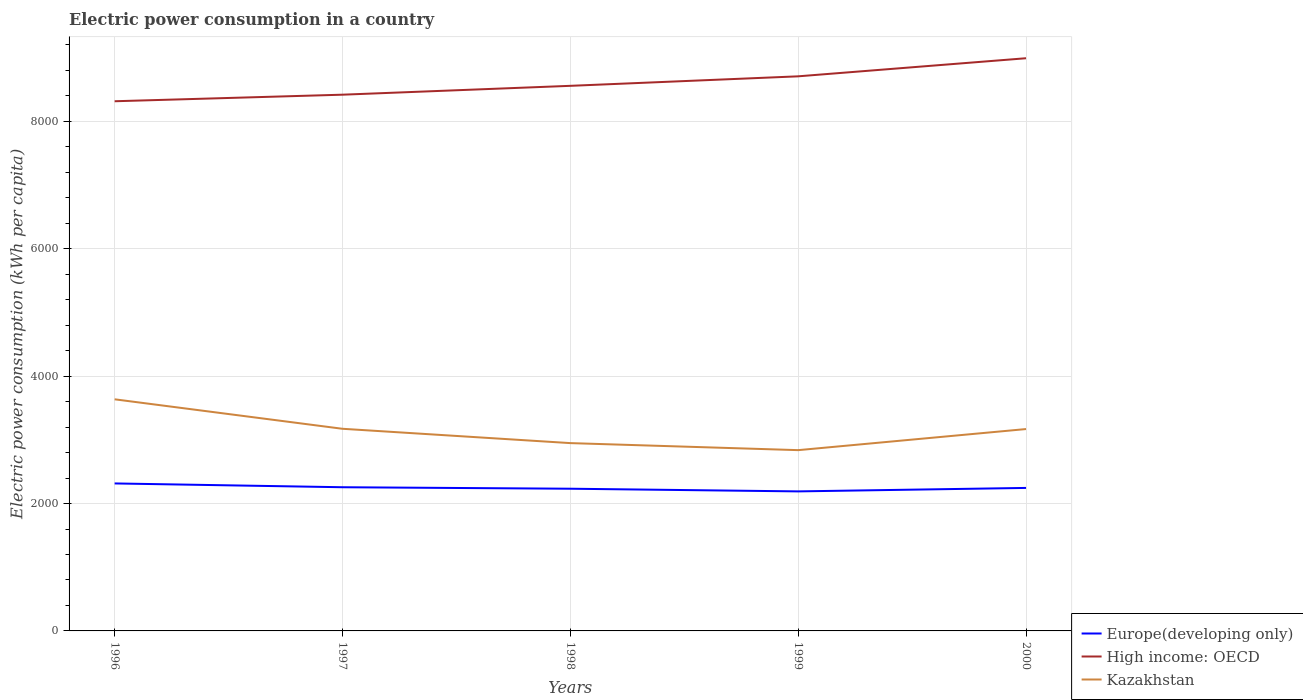Across all years, what is the maximum electric power consumption in in Europe(developing only)?
Provide a short and direct response. 2190.83. What is the total electric power consumption in in Europe(developing only) in the graph?
Offer a terse response. -12.46. What is the difference between the highest and the second highest electric power consumption in in Europe(developing only)?
Give a very brief answer. 124.9. What is the difference between the highest and the lowest electric power consumption in in Kazakhstan?
Make the answer very short. 3. Is the electric power consumption in in Kazakhstan strictly greater than the electric power consumption in in High income: OECD over the years?
Ensure brevity in your answer.  Yes. How many lines are there?
Make the answer very short. 3. How many years are there in the graph?
Your answer should be compact. 5. What is the difference between two consecutive major ticks on the Y-axis?
Offer a terse response. 2000. How many legend labels are there?
Ensure brevity in your answer.  3. How are the legend labels stacked?
Offer a very short reply. Vertical. What is the title of the graph?
Provide a succinct answer. Electric power consumption in a country. Does "El Salvador" appear as one of the legend labels in the graph?
Provide a short and direct response. No. What is the label or title of the X-axis?
Your answer should be very brief. Years. What is the label or title of the Y-axis?
Give a very brief answer. Electric power consumption (kWh per capita). What is the Electric power consumption (kWh per capita) of Europe(developing only) in 1996?
Your answer should be very brief. 2315.73. What is the Electric power consumption (kWh per capita) of High income: OECD in 1996?
Offer a very short reply. 8316.45. What is the Electric power consumption (kWh per capita) in Kazakhstan in 1996?
Your answer should be compact. 3636.63. What is the Electric power consumption (kWh per capita) of Europe(developing only) in 1997?
Offer a very short reply. 2256.15. What is the Electric power consumption (kWh per capita) of High income: OECD in 1997?
Give a very brief answer. 8419.43. What is the Electric power consumption (kWh per capita) of Kazakhstan in 1997?
Provide a succinct answer. 3173.79. What is the Electric power consumption (kWh per capita) of Europe(developing only) in 1998?
Make the answer very short. 2232.69. What is the Electric power consumption (kWh per capita) of High income: OECD in 1998?
Give a very brief answer. 8558.64. What is the Electric power consumption (kWh per capita) in Kazakhstan in 1998?
Make the answer very short. 2948.78. What is the Electric power consumption (kWh per capita) in Europe(developing only) in 1999?
Your response must be concise. 2190.83. What is the Electric power consumption (kWh per capita) of High income: OECD in 1999?
Your response must be concise. 8707.81. What is the Electric power consumption (kWh per capita) in Kazakhstan in 1999?
Your answer should be very brief. 2838.34. What is the Electric power consumption (kWh per capita) in Europe(developing only) in 2000?
Your response must be concise. 2245.15. What is the Electric power consumption (kWh per capita) of High income: OECD in 2000?
Provide a succinct answer. 8991.83. What is the Electric power consumption (kWh per capita) in Kazakhstan in 2000?
Provide a succinct answer. 3169.52. Across all years, what is the maximum Electric power consumption (kWh per capita) in Europe(developing only)?
Your response must be concise. 2315.73. Across all years, what is the maximum Electric power consumption (kWh per capita) in High income: OECD?
Your response must be concise. 8991.83. Across all years, what is the maximum Electric power consumption (kWh per capita) of Kazakhstan?
Give a very brief answer. 3636.63. Across all years, what is the minimum Electric power consumption (kWh per capita) in Europe(developing only)?
Ensure brevity in your answer.  2190.83. Across all years, what is the minimum Electric power consumption (kWh per capita) of High income: OECD?
Provide a succinct answer. 8316.45. Across all years, what is the minimum Electric power consumption (kWh per capita) of Kazakhstan?
Provide a short and direct response. 2838.34. What is the total Electric power consumption (kWh per capita) in Europe(developing only) in the graph?
Your answer should be compact. 1.12e+04. What is the total Electric power consumption (kWh per capita) in High income: OECD in the graph?
Make the answer very short. 4.30e+04. What is the total Electric power consumption (kWh per capita) in Kazakhstan in the graph?
Provide a succinct answer. 1.58e+04. What is the difference between the Electric power consumption (kWh per capita) of Europe(developing only) in 1996 and that in 1997?
Provide a short and direct response. 59.58. What is the difference between the Electric power consumption (kWh per capita) in High income: OECD in 1996 and that in 1997?
Offer a very short reply. -102.97. What is the difference between the Electric power consumption (kWh per capita) in Kazakhstan in 1996 and that in 1997?
Make the answer very short. 462.83. What is the difference between the Electric power consumption (kWh per capita) in Europe(developing only) in 1996 and that in 1998?
Offer a terse response. 83.04. What is the difference between the Electric power consumption (kWh per capita) of High income: OECD in 1996 and that in 1998?
Your answer should be compact. -242.18. What is the difference between the Electric power consumption (kWh per capita) of Kazakhstan in 1996 and that in 1998?
Your answer should be very brief. 687.84. What is the difference between the Electric power consumption (kWh per capita) in Europe(developing only) in 1996 and that in 1999?
Offer a very short reply. 124.9. What is the difference between the Electric power consumption (kWh per capita) in High income: OECD in 1996 and that in 1999?
Provide a succinct answer. -391.35. What is the difference between the Electric power consumption (kWh per capita) of Kazakhstan in 1996 and that in 1999?
Ensure brevity in your answer.  798.28. What is the difference between the Electric power consumption (kWh per capita) of Europe(developing only) in 1996 and that in 2000?
Provide a succinct answer. 70.58. What is the difference between the Electric power consumption (kWh per capita) of High income: OECD in 1996 and that in 2000?
Give a very brief answer. -675.37. What is the difference between the Electric power consumption (kWh per capita) in Kazakhstan in 1996 and that in 2000?
Provide a short and direct response. 467.1. What is the difference between the Electric power consumption (kWh per capita) of Europe(developing only) in 1997 and that in 1998?
Your response must be concise. 23.46. What is the difference between the Electric power consumption (kWh per capita) of High income: OECD in 1997 and that in 1998?
Offer a terse response. -139.21. What is the difference between the Electric power consumption (kWh per capita) in Kazakhstan in 1997 and that in 1998?
Your response must be concise. 225.01. What is the difference between the Electric power consumption (kWh per capita) of Europe(developing only) in 1997 and that in 1999?
Keep it short and to the point. 65.32. What is the difference between the Electric power consumption (kWh per capita) of High income: OECD in 1997 and that in 1999?
Offer a terse response. -288.38. What is the difference between the Electric power consumption (kWh per capita) in Kazakhstan in 1997 and that in 1999?
Make the answer very short. 335.45. What is the difference between the Electric power consumption (kWh per capita) of Europe(developing only) in 1997 and that in 2000?
Provide a short and direct response. 11. What is the difference between the Electric power consumption (kWh per capita) of High income: OECD in 1997 and that in 2000?
Your answer should be compact. -572.4. What is the difference between the Electric power consumption (kWh per capita) in Kazakhstan in 1997 and that in 2000?
Offer a very short reply. 4.27. What is the difference between the Electric power consumption (kWh per capita) of Europe(developing only) in 1998 and that in 1999?
Your answer should be very brief. 41.86. What is the difference between the Electric power consumption (kWh per capita) in High income: OECD in 1998 and that in 1999?
Offer a very short reply. -149.17. What is the difference between the Electric power consumption (kWh per capita) in Kazakhstan in 1998 and that in 1999?
Provide a short and direct response. 110.44. What is the difference between the Electric power consumption (kWh per capita) in Europe(developing only) in 1998 and that in 2000?
Provide a succinct answer. -12.46. What is the difference between the Electric power consumption (kWh per capita) of High income: OECD in 1998 and that in 2000?
Ensure brevity in your answer.  -433.19. What is the difference between the Electric power consumption (kWh per capita) in Kazakhstan in 1998 and that in 2000?
Offer a terse response. -220.74. What is the difference between the Electric power consumption (kWh per capita) in Europe(developing only) in 1999 and that in 2000?
Keep it short and to the point. -54.33. What is the difference between the Electric power consumption (kWh per capita) of High income: OECD in 1999 and that in 2000?
Your response must be concise. -284.02. What is the difference between the Electric power consumption (kWh per capita) in Kazakhstan in 1999 and that in 2000?
Keep it short and to the point. -331.18. What is the difference between the Electric power consumption (kWh per capita) in Europe(developing only) in 1996 and the Electric power consumption (kWh per capita) in High income: OECD in 1997?
Offer a terse response. -6103.7. What is the difference between the Electric power consumption (kWh per capita) of Europe(developing only) in 1996 and the Electric power consumption (kWh per capita) of Kazakhstan in 1997?
Your response must be concise. -858.06. What is the difference between the Electric power consumption (kWh per capita) of High income: OECD in 1996 and the Electric power consumption (kWh per capita) of Kazakhstan in 1997?
Provide a short and direct response. 5142.66. What is the difference between the Electric power consumption (kWh per capita) of Europe(developing only) in 1996 and the Electric power consumption (kWh per capita) of High income: OECD in 1998?
Give a very brief answer. -6242.91. What is the difference between the Electric power consumption (kWh per capita) in Europe(developing only) in 1996 and the Electric power consumption (kWh per capita) in Kazakhstan in 1998?
Provide a succinct answer. -633.05. What is the difference between the Electric power consumption (kWh per capita) of High income: OECD in 1996 and the Electric power consumption (kWh per capita) of Kazakhstan in 1998?
Provide a short and direct response. 5367.67. What is the difference between the Electric power consumption (kWh per capita) of Europe(developing only) in 1996 and the Electric power consumption (kWh per capita) of High income: OECD in 1999?
Offer a terse response. -6392.08. What is the difference between the Electric power consumption (kWh per capita) of Europe(developing only) in 1996 and the Electric power consumption (kWh per capita) of Kazakhstan in 1999?
Ensure brevity in your answer.  -522.61. What is the difference between the Electric power consumption (kWh per capita) in High income: OECD in 1996 and the Electric power consumption (kWh per capita) in Kazakhstan in 1999?
Your answer should be very brief. 5478.11. What is the difference between the Electric power consumption (kWh per capita) in Europe(developing only) in 1996 and the Electric power consumption (kWh per capita) in High income: OECD in 2000?
Offer a very short reply. -6676.1. What is the difference between the Electric power consumption (kWh per capita) in Europe(developing only) in 1996 and the Electric power consumption (kWh per capita) in Kazakhstan in 2000?
Make the answer very short. -853.79. What is the difference between the Electric power consumption (kWh per capita) of High income: OECD in 1996 and the Electric power consumption (kWh per capita) of Kazakhstan in 2000?
Ensure brevity in your answer.  5146.93. What is the difference between the Electric power consumption (kWh per capita) in Europe(developing only) in 1997 and the Electric power consumption (kWh per capita) in High income: OECD in 1998?
Provide a short and direct response. -6302.49. What is the difference between the Electric power consumption (kWh per capita) in Europe(developing only) in 1997 and the Electric power consumption (kWh per capita) in Kazakhstan in 1998?
Offer a terse response. -692.64. What is the difference between the Electric power consumption (kWh per capita) in High income: OECD in 1997 and the Electric power consumption (kWh per capita) in Kazakhstan in 1998?
Make the answer very short. 5470.64. What is the difference between the Electric power consumption (kWh per capita) of Europe(developing only) in 1997 and the Electric power consumption (kWh per capita) of High income: OECD in 1999?
Ensure brevity in your answer.  -6451.66. What is the difference between the Electric power consumption (kWh per capita) in Europe(developing only) in 1997 and the Electric power consumption (kWh per capita) in Kazakhstan in 1999?
Provide a succinct answer. -582.2. What is the difference between the Electric power consumption (kWh per capita) in High income: OECD in 1997 and the Electric power consumption (kWh per capita) in Kazakhstan in 1999?
Offer a very short reply. 5581.08. What is the difference between the Electric power consumption (kWh per capita) in Europe(developing only) in 1997 and the Electric power consumption (kWh per capita) in High income: OECD in 2000?
Your answer should be compact. -6735.68. What is the difference between the Electric power consumption (kWh per capita) in Europe(developing only) in 1997 and the Electric power consumption (kWh per capita) in Kazakhstan in 2000?
Provide a short and direct response. -913.38. What is the difference between the Electric power consumption (kWh per capita) in High income: OECD in 1997 and the Electric power consumption (kWh per capita) in Kazakhstan in 2000?
Your response must be concise. 5249.9. What is the difference between the Electric power consumption (kWh per capita) in Europe(developing only) in 1998 and the Electric power consumption (kWh per capita) in High income: OECD in 1999?
Keep it short and to the point. -6475.12. What is the difference between the Electric power consumption (kWh per capita) of Europe(developing only) in 1998 and the Electric power consumption (kWh per capita) of Kazakhstan in 1999?
Provide a short and direct response. -605.65. What is the difference between the Electric power consumption (kWh per capita) in High income: OECD in 1998 and the Electric power consumption (kWh per capita) in Kazakhstan in 1999?
Ensure brevity in your answer.  5720.29. What is the difference between the Electric power consumption (kWh per capita) in Europe(developing only) in 1998 and the Electric power consumption (kWh per capita) in High income: OECD in 2000?
Your answer should be compact. -6759.14. What is the difference between the Electric power consumption (kWh per capita) in Europe(developing only) in 1998 and the Electric power consumption (kWh per capita) in Kazakhstan in 2000?
Your answer should be compact. -936.83. What is the difference between the Electric power consumption (kWh per capita) in High income: OECD in 1998 and the Electric power consumption (kWh per capita) in Kazakhstan in 2000?
Offer a very short reply. 5389.11. What is the difference between the Electric power consumption (kWh per capita) of Europe(developing only) in 1999 and the Electric power consumption (kWh per capita) of High income: OECD in 2000?
Offer a very short reply. -6801. What is the difference between the Electric power consumption (kWh per capita) in Europe(developing only) in 1999 and the Electric power consumption (kWh per capita) in Kazakhstan in 2000?
Give a very brief answer. -978.7. What is the difference between the Electric power consumption (kWh per capita) in High income: OECD in 1999 and the Electric power consumption (kWh per capita) in Kazakhstan in 2000?
Your answer should be very brief. 5538.28. What is the average Electric power consumption (kWh per capita) in Europe(developing only) per year?
Ensure brevity in your answer.  2248.11. What is the average Electric power consumption (kWh per capita) in High income: OECD per year?
Keep it short and to the point. 8598.83. What is the average Electric power consumption (kWh per capita) in Kazakhstan per year?
Ensure brevity in your answer.  3153.41. In the year 1996, what is the difference between the Electric power consumption (kWh per capita) in Europe(developing only) and Electric power consumption (kWh per capita) in High income: OECD?
Your response must be concise. -6000.72. In the year 1996, what is the difference between the Electric power consumption (kWh per capita) of Europe(developing only) and Electric power consumption (kWh per capita) of Kazakhstan?
Provide a short and direct response. -1320.9. In the year 1996, what is the difference between the Electric power consumption (kWh per capita) of High income: OECD and Electric power consumption (kWh per capita) of Kazakhstan?
Make the answer very short. 4679.82. In the year 1997, what is the difference between the Electric power consumption (kWh per capita) of Europe(developing only) and Electric power consumption (kWh per capita) of High income: OECD?
Your answer should be very brief. -6163.28. In the year 1997, what is the difference between the Electric power consumption (kWh per capita) of Europe(developing only) and Electric power consumption (kWh per capita) of Kazakhstan?
Provide a short and direct response. -917.65. In the year 1997, what is the difference between the Electric power consumption (kWh per capita) in High income: OECD and Electric power consumption (kWh per capita) in Kazakhstan?
Your answer should be very brief. 5245.63. In the year 1998, what is the difference between the Electric power consumption (kWh per capita) of Europe(developing only) and Electric power consumption (kWh per capita) of High income: OECD?
Make the answer very short. -6325.95. In the year 1998, what is the difference between the Electric power consumption (kWh per capita) of Europe(developing only) and Electric power consumption (kWh per capita) of Kazakhstan?
Make the answer very short. -716.09. In the year 1998, what is the difference between the Electric power consumption (kWh per capita) in High income: OECD and Electric power consumption (kWh per capita) in Kazakhstan?
Your answer should be very brief. 5609.85. In the year 1999, what is the difference between the Electric power consumption (kWh per capita) of Europe(developing only) and Electric power consumption (kWh per capita) of High income: OECD?
Your response must be concise. -6516.98. In the year 1999, what is the difference between the Electric power consumption (kWh per capita) in Europe(developing only) and Electric power consumption (kWh per capita) in Kazakhstan?
Your answer should be very brief. -647.52. In the year 1999, what is the difference between the Electric power consumption (kWh per capita) of High income: OECD and Electric power consumption (kWh per capita) of Kazakhstan?
Provide a short and direct response. 5869.46. In the year 2000, what is the difference between the Electric power consumption (kWh per capita) of Europe(developing only) and Electric power consumption (kWh per capita) of High income: OECD?
Your answer should be compact. -6746.67. In the year 2000, what is the difference between the Electric power consumption (kWh per capita) of Europe(developing only) and Electric power consumption (kWh per capita) of Kazakhstan?
Your answer should be very brief. -924.37. In the year 2000, what is the difference between the Electric power consumption (kWh per capita) of High income: OECD and Electric power consumption (kWh per capita) of Kazakhstan?
Offer a very short reply. 5822.3. What is the ratio of the Electric power consumption (kWh per capita) of Europe(developing only) in 1996 to that in 1997?
Your response must be concise. 1.03. What is the ratio of the Electric power consumption (kWh per capita) of High income: OECD in 1996 to that in 1997?
Your answer should be compact. 0.99. What is the ratio of the Electric power consumption (kWh per capita) in Kazakhstan in 1996 to that in 1997?
Your answer should be compact. 1.15. What is the ratio of the Electric power consumption (kWh per capita) in Europe(developing only) in 1996 to that in 1998?
Your response must be concise. 1.04. What is the ratio of the Electric power consumption (kWh per capita) of High income: OECD in 1996 to that in 1998?
Keep it short and to the point. 0.97. What is the ratio of the Electric power consumption (kWh per capita) of Kazakhstan in 1996 to that in 1998?
Your answer should be very brief. 1.23. What is the ratio of the Electric power consumption (kWh per capita) in Europe(developing only) in 1996 to that in 1999?
Offer a terse response. 1.06. What is the ratio of the Electric power consumption (kWh per capita) in High income: OECD in 1996 to that in 1999?
Give a very brief answer. 0.96. What is the ratio of the Electric power consumption (kWh per capita) in Kazakhstan in 1996 to that in 1999?
Your answer should be very brief. 1.28. What is the ratio of the Electric power consumption (kWh per capita) in Europe(developing only) in 1996 to that in 2000?
Give a very brief answer. 1.03. What is the ratio of the Electric power consumption (kWh per capita) in High income: OECD in 1996 to that in 2000?
Offer a terse response. 0.92. What is the ratio of the Electric power consumption (kWh per capita) of Kazakhstan in 1996 to that in 2000?
Keep it short and to the point. 1.15. What is the ratio of the Electric power consumption (kWh per capita) of Europe(developing only) in 1997 to that in 1998?
Your answer should be very brief. 1.01. What is the ratio of the Electric power consumption (kWh per capita) in High income: OECD in 1997 to that in 1998?
Your response must be concise. 0.98. What is the ratio of the Electric power consumption (kWh per capita) of Kazakhstan in 1997 to that in 1998?
Your answer should be very brief. 1.08. What is the ratio of the Electric power consumption (kWh per capita) in Europe(developing only) in 1997 to that in 1999?
Make the answer very short. 1.03. What is the ratio of the Electric power consumption (kWh per capita) of High income: OECD in 1997 to that in 1999?
Keep it short and to the point. 0.97. What is the ratio of the Electric power consumption (kWh per capita) in Kazakhstan in 1997 to that in 1999?
Give a very brief answer. 1.12. What is the ratio of the Electric power consumption (kWh per capita) in Europe(developing only) in 1997 to that in 2000?
Keep it short and to the point. 1. What is the ratio of the Electric power consumption (kWh per capita) of High income: OECD in 1997 to that in 2000?
Keep it short and to the point. 0.94. What is the ratio of the Electric power consumption (kWh per capita) in Europe(developing only) in 1998 to that in 1999?
Your answer should be very brief. 1.02. What is the ratio of the Electric power consumption (kWh per capita) in High income: OECD in 1998 to that in 1999?
Your response must be concise. 0.98. What is the ratio of the Electric power consumption (kWh per capita) of Kazakhstan in 1998 to that in 1999?
Give a very brief answer. 1.04. What is the ratio of the Electric power consumption (kWh per capita) in High income: OECD in 1998 to that in 2000?
Provide a short and direct response. 0.95. What is the ratio of the Electric power consumption (kWh per capita) of Kazakhstan in 1998 to that in 2000?
Make the answer very short. 0.93. What is the ratio of the Electric power consumption (kWh per capita) of Europe(developing only) in 1999 to that in 2000?
Your response must be concise. 0.98. What is the ratio of the Electric power consumption (kWh per capita) of High income: OECD in 1999 to that in 2000?
Ensure brevity in your answer.  0.97. What is the ratio of the Electric power consumption (kWh per capita) in Kazakhstan in 1999 to that in 2000?
Your answer should be compact. 0.9. What is the difference between the highest and the second highest Electric power consumption (kWh per capita) of Europe(developing only)?
Provide a short and direct response. 59.58. What is the difference between the highest and the second highest Electric power consumption (kWh per capita) of High income: OECD?
Provide a short and direct response. 284.02. What is the difference between the highest and the second highest Electric power consumption (kWh per capita) in Kazakhstan?
Your response must be concise. 462.83. What is the difference between the highest and the lowest Electric power consumption (kWh per capita) in Europe(developing only)?
Offer a terse response. 124.9. What is the difference between the highest and the lowest Electric power consumption (kWh per capita) in High income: OECD?
Give a very brief answer. 675.37. What is the difference between the highest and the lowest Electric power consumption (kWh per capita) of Kazakhstan?
Your answer should be very brief. 798.28. 